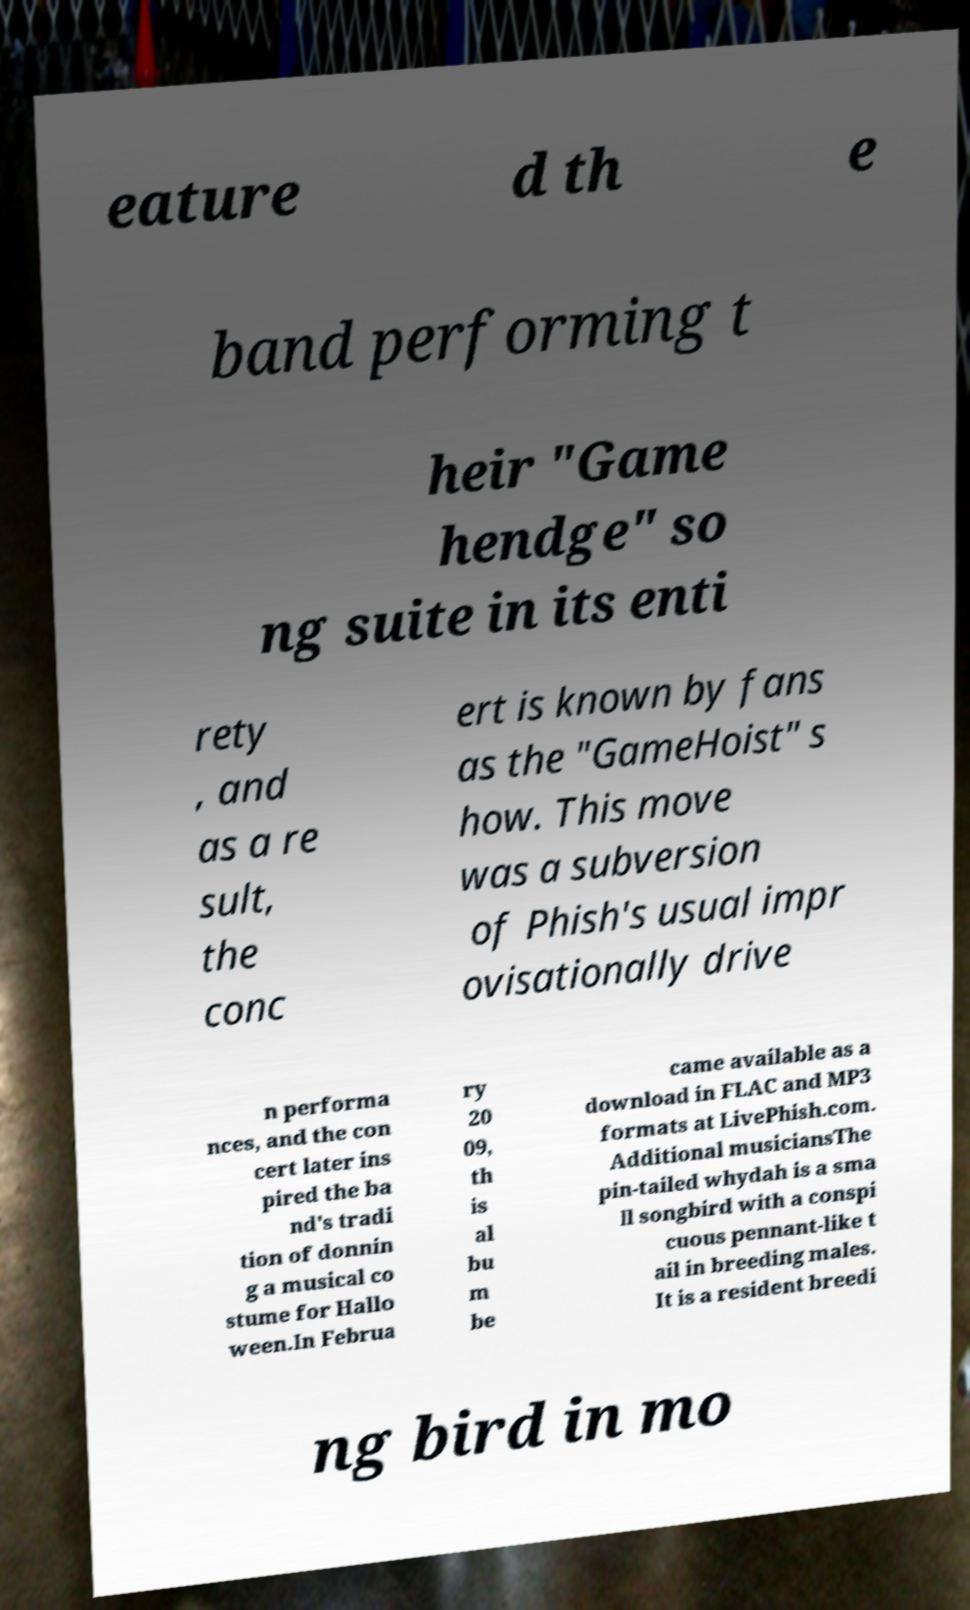I need the written content from this picture converted into text. Can you do that? eature d th e band performing t heir "Game hendge" so ng suite in its enti rety , and as a re sult, the conc ert is known by fans as the "GameHoist" s how. This move was a subversion of Phish's usual impr ovisationally drive n performa nces, and the con cert later ins pired the ba nd's tradi tion of donnin g a musical co stume for Hallo ween.In Februa ry 20 09, th is al bu m be came available as a download in FLAC and MP3 formats at LivePhish.com. Additional musiciansThe pin-tailed whydah is a sma ll songbird with a conspi cuous pennant-like t ail in breeding males. It is a resident breedi ng bird in mo 